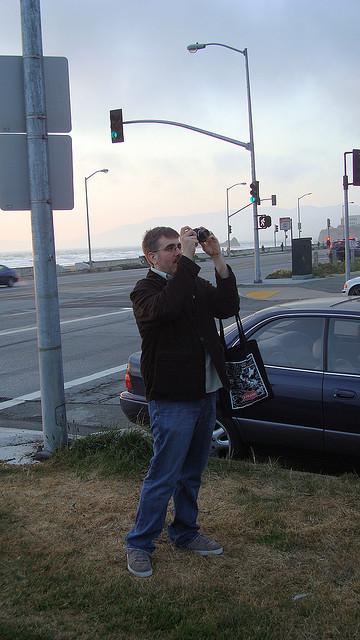What color is the car?
Be succinct. Black. Where are his hands?
Concise answer only. Holding camera. What is this man doing?
Be succinct. Taking picture. When the ride is over, what must one do to exit the car?
Concise answer only. Open door. What color is the traffic light?
Short answer required. Green. Is the street busy or clear?
Be succinct. Clear. What sign is near the man?
Short answer required. Unknown. 